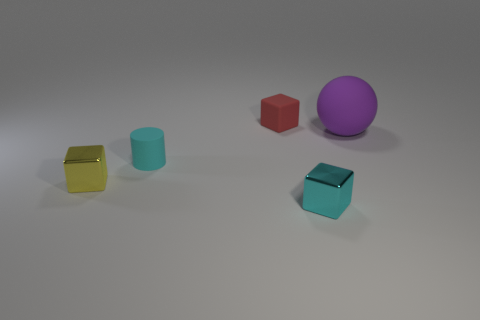Subtract all small metallic cubes. How many cubes are left? 1 Add 5 cyan matte things. How many objects exist? 10 Subtract all balls. How many objects are left? 4 Add 2 balls. How many balls exist? 3 Subtract 0 red cylinders. How many objects are left? 5 Subtract all cyan matte objects. Subtract all large balls. How many objects are left? 3 Add 1 small cubes. How many small cubes are left? 4 